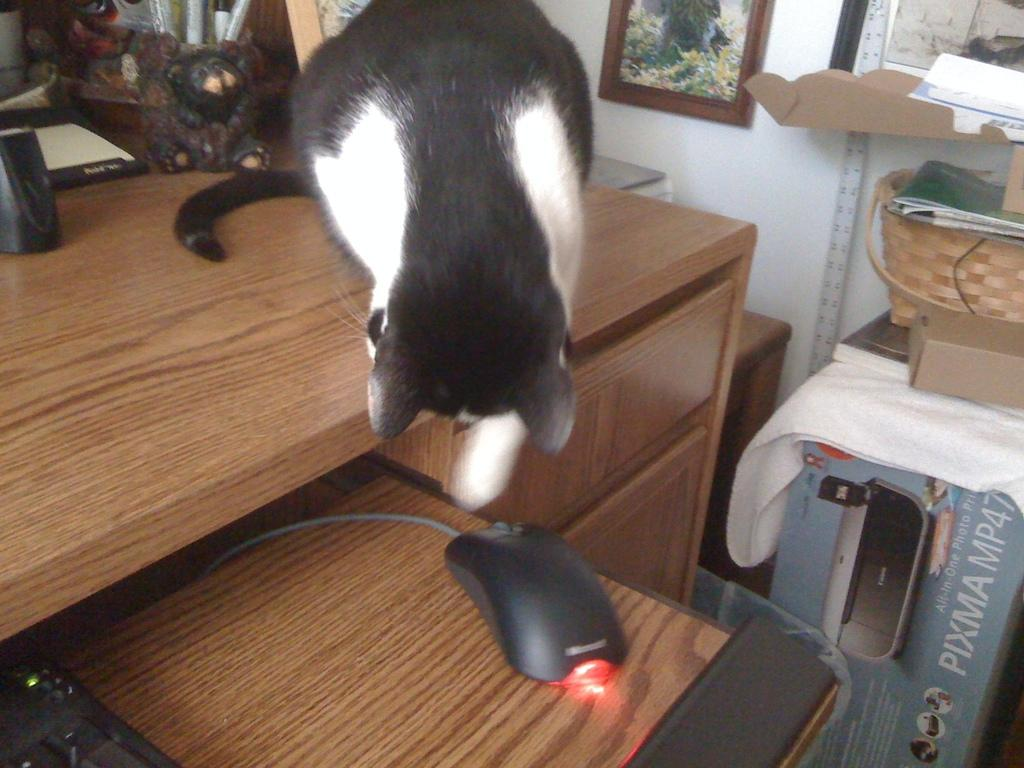What type of animal can be seen in the image? There is a cat in the image. What other animal is present in the image? There is a mouse in the image. What object is commonly used for typing? There is a keyboard in the image. What object might be used for carrying items? There is a basket in the image. What object is typically used for storing items? There is a box in the image. What piece of furniture is present in the image? There is a table in the image. What type of decoration is on the wall in the image? There is a frame on the wall in the image. What type of nail is being used by the expert in the image? There is no expert or nail present in the image. What type of collar is the cat wearing in the image? The cat is not wearing a collar in the image. 